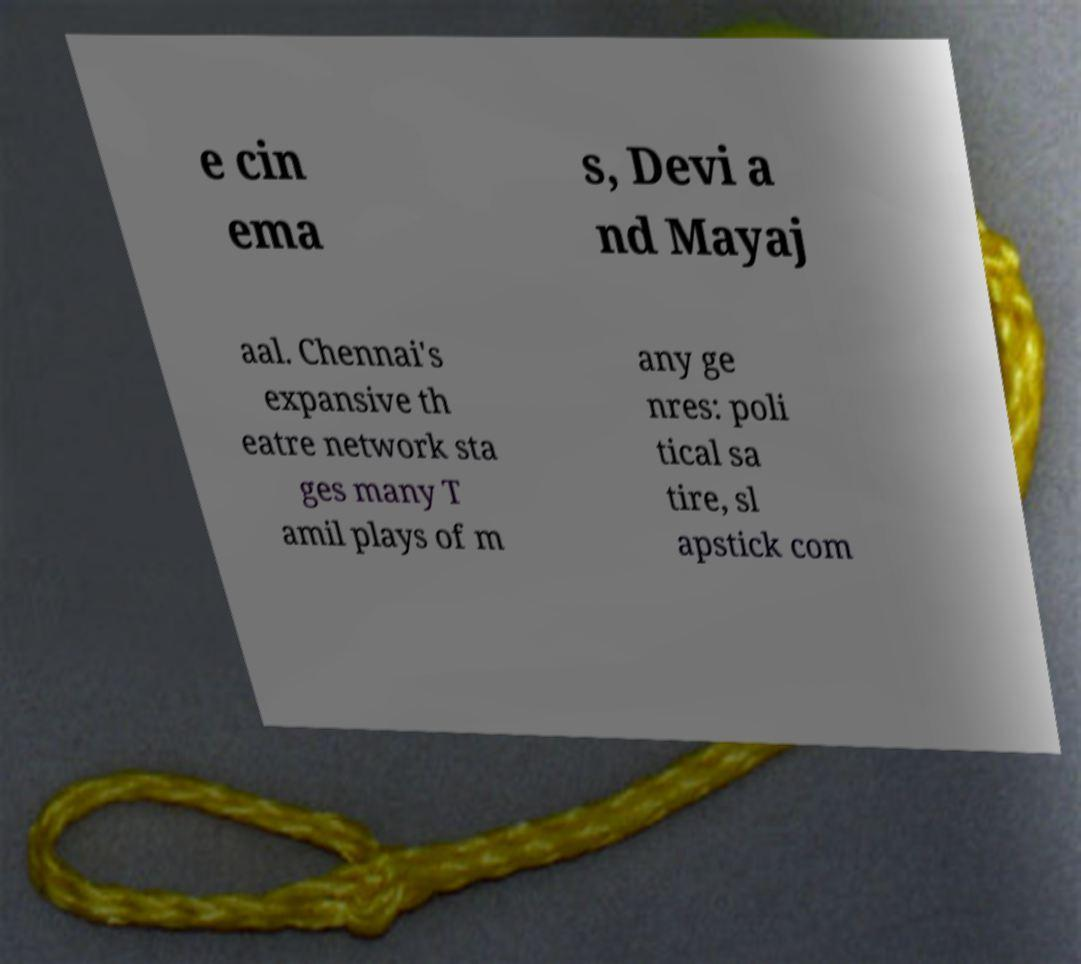Can you accurately transcribe the text from the provided image for me? e cin ema s, Devi a nd Mayaj aal. Chennai's expansive th eatre network sta ges many T amil plays of m any ge nres: poli tical sa tire, sl apstick com 